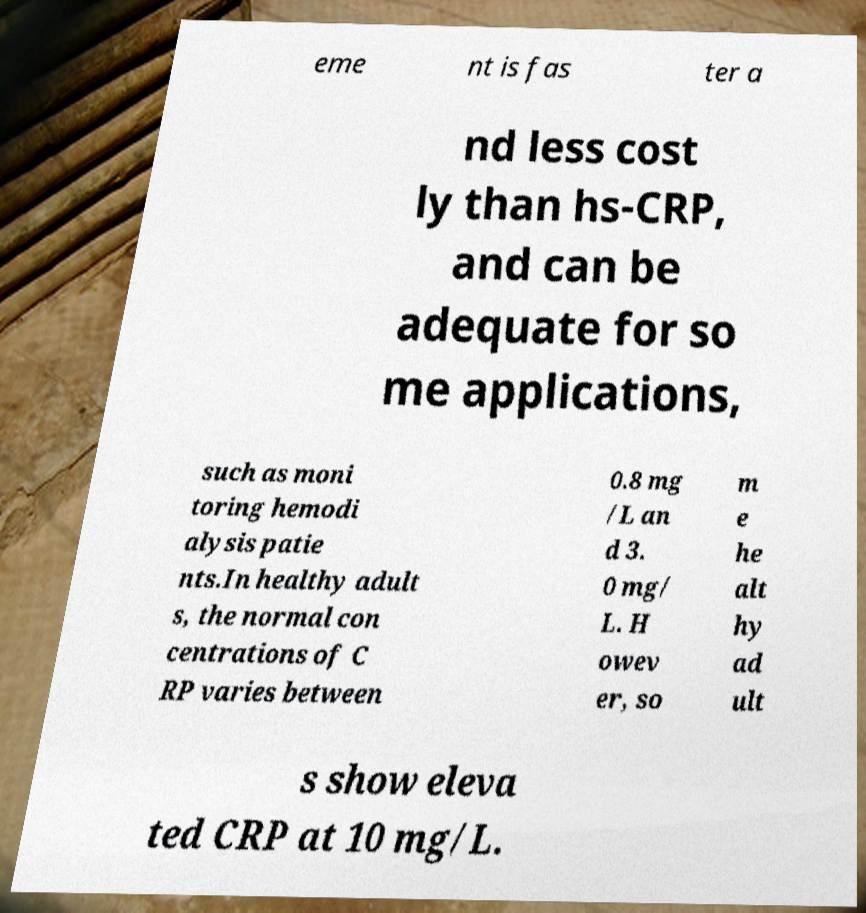Could you assist in decoding the text presented in this image and type it out clearly? eme nt is fas ter a nd less cost ly than hs-CRP, and can be adequate for so me applications, such as moni toring hemodi alysis patie nts.In healthy adult s, the normal con centrations of C RP varies between 0.8 mg /L an d 3. 0 mg/ L. H owev er, so m e he alt hy ad ult s show eleva ted CRP at 10 mg/L. 